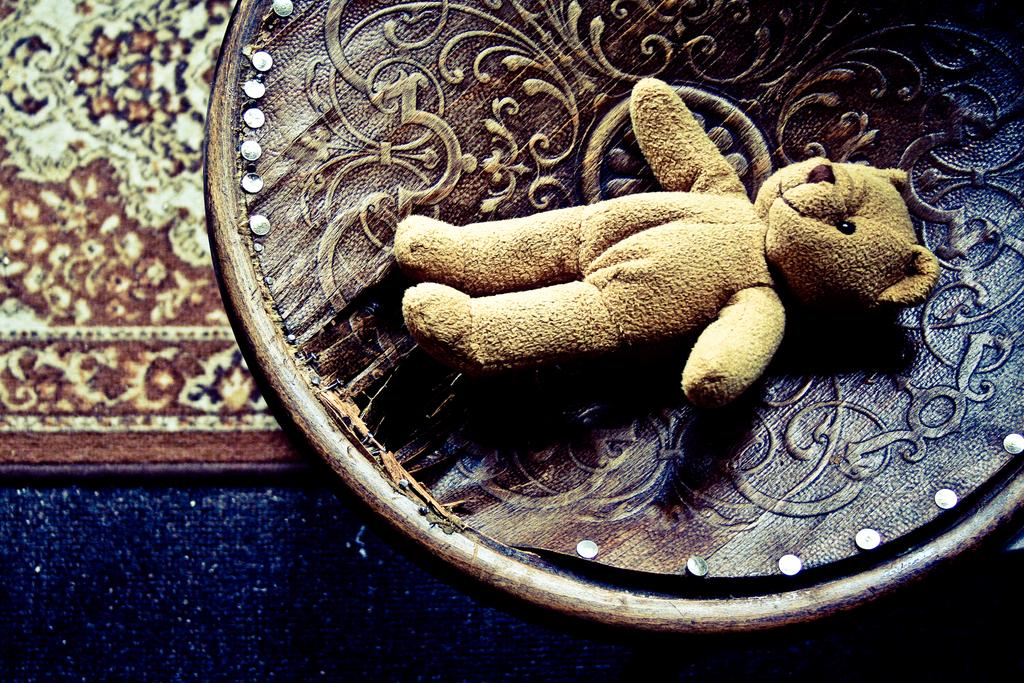What type of surface is visible in the image? There is a ground with a mat in the image. What else can be seen in the image besides the ground and mat? There is an object in the image. What is placed on the object in the image? There is a toy on the object in the image. How many boots are visible in the image? There are no boots present in the image. What type of tramp can be seen jumping in the image? There is no tramp or jumping activity depicted in the image. 